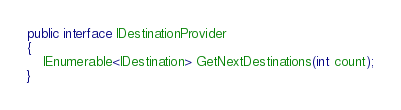Convert code to text. <code><loc_0><loc_0><loc_500><loc_500><_C#_>public interface IDestinationProvider
{
	IEnumerable<IDestination> GetNextDestinations(int count);
}
</code> 